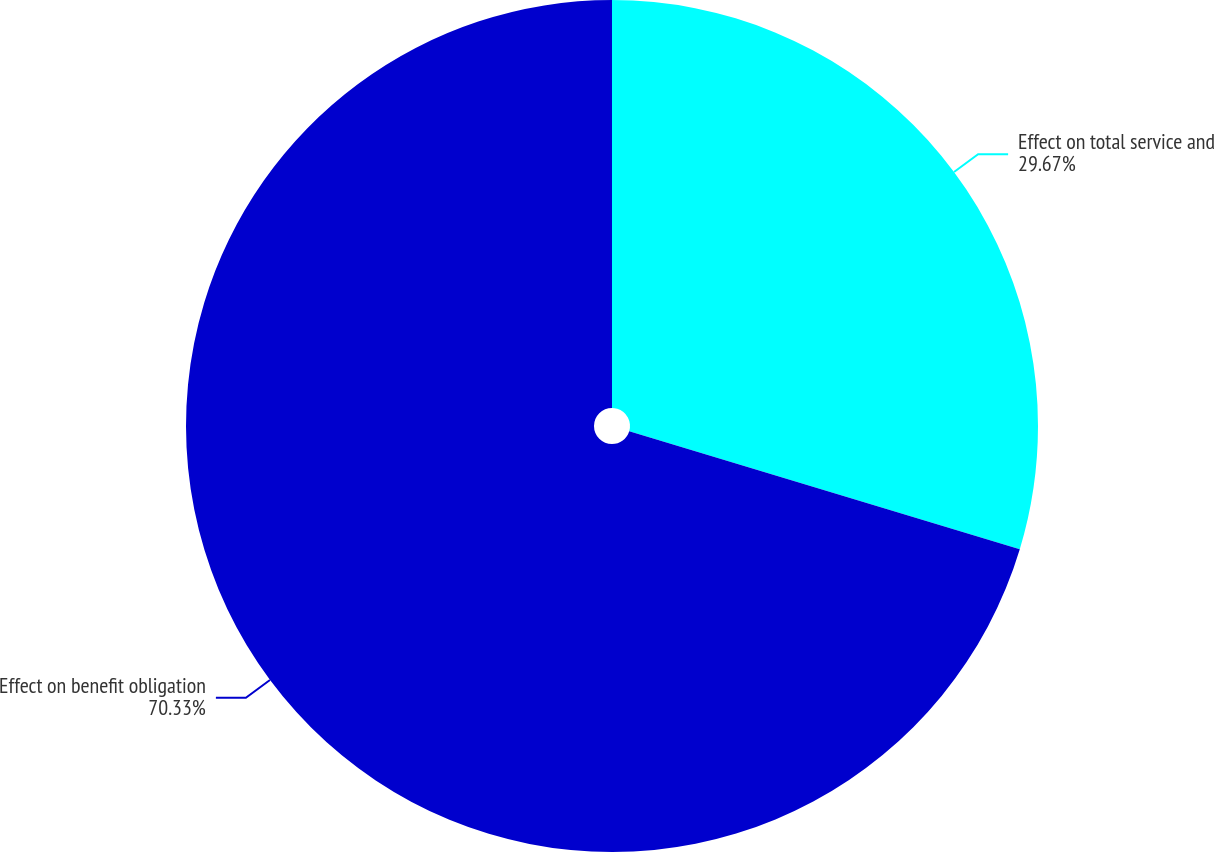<chart> <loc_0><loc_0><loc_500><loc_500><pie_chart><fcel>Effect on total service and<fcel>Effect on benefit obligation<nl><fcel>29.67%<fcel>70.33%<nl></chart> 